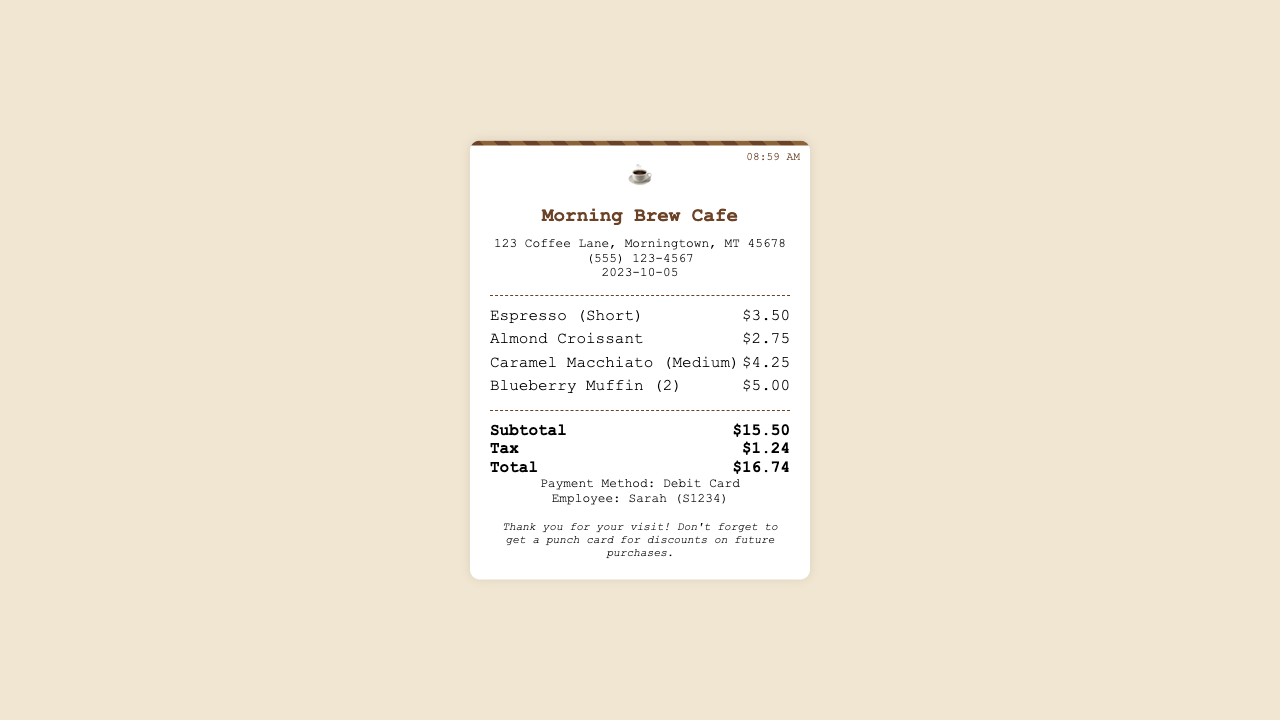What is the name of the cafe? The name of the cafe is displayed prominently at the top of the receipt.
Answer: Morning Brew Cafe What is the date of the purchase? The date can be found in the information section of the receipt.
Answer: 2023-10-05 How much did the Espresso cost? The cost of the Espresso is listed next to the item in the receipt's itemized list.
Answer: $3.50 What is the total amount spent? The total amount is calculated at the bottom of the receipt, summing subtotal and tax.
Answer: $16.74 Who is the employee that served the customer? The employee's name is provided in the information section at the bottom of the receipt.
Answer: Sarah (S1234) How many Blueberry Muffins were purchased? The number of Blueberry Muffins is indicated in parentheses next to the item description on the receipt.
Answer: 2 What payment method was used? The payment method is found in the information section at the bottom of the receipt.
Answer: Debit Card What was the subtotal before tax? The subtotal is listed separately before tax calculations in the receipt.
Answer: $15.50 What time was the purchase made? The time is indicated in the top right corner of the receipt.
Answer: 08:59 AM 